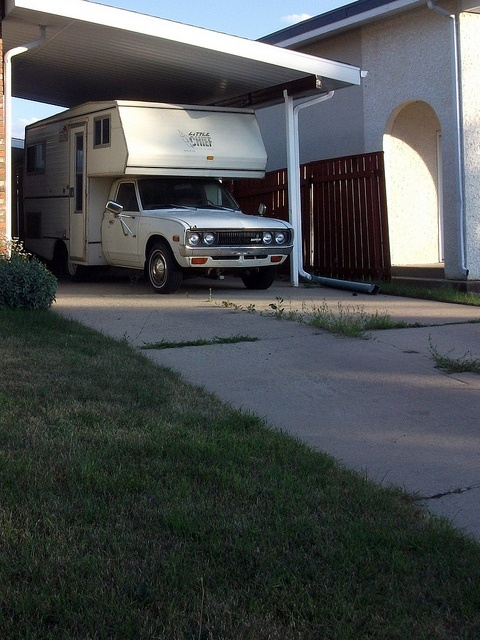Describe the objects in this image and their specific colors. I can see a truck in black, gray, ivory, and darkgray tones in this image. 